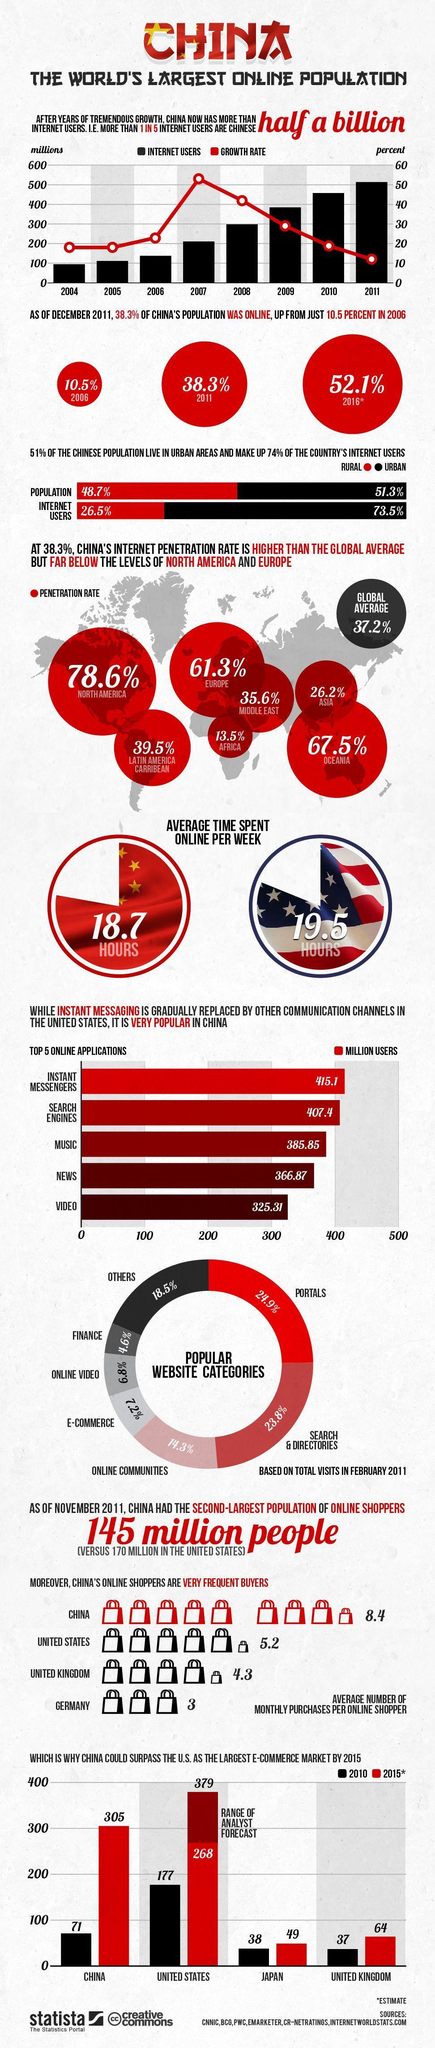when was the number of internet users in China surpassed 500 million?
Answer the question with a short phrase. 2011 what is the e-commerce market of US in 2010 according to the bar chart? 177 users of which country purchases online more frequently - US or UK? US which is the second most popular website category among Chinese internet users? search & directories what is the estimated e-commerce market of China by 2015 according to the bar chart? 305 what percent of internet users in China live in rural areas? 26.5% what was the number of internet users in millions in China in 2008? 300 which is the most popular website category among Chinese internet users? portals what percent of Chinese population live in rural areas? 48.7 what is the e-commerce market of Japan in 2010 according to the bar chart? 38 which country has largest population of online shoppers? United states what is the number of users of instant messenger application in China in millions? 415.1 what is the number of users of music application in China in millions? 385.85 users of which country purchases online more frequently - China, Germany or UK? China which regions have internet penetration rate less than global average? Asia, Africa, middle east 